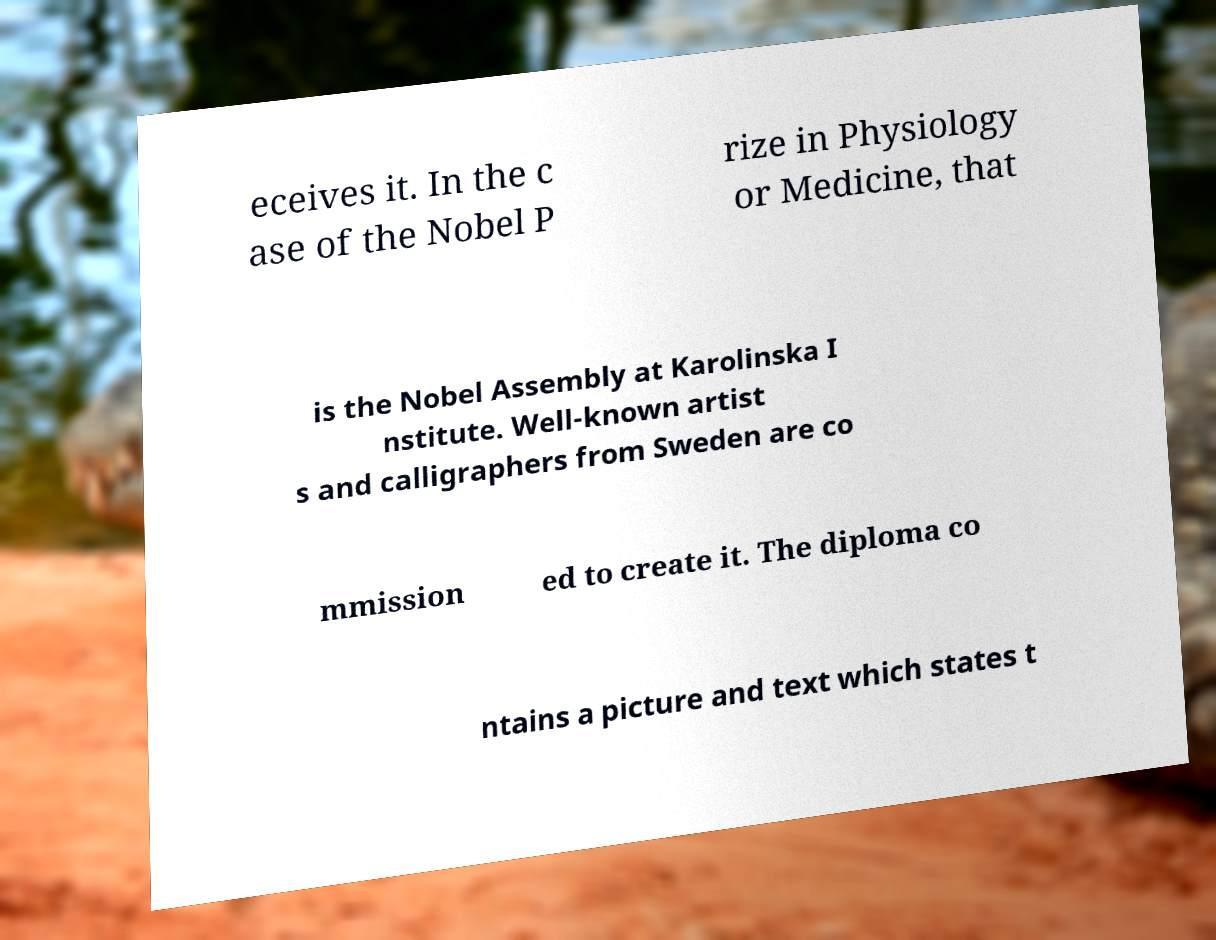Please read and relay the text visible in this image. What does it say? eceives it. In the c ase of the Nobel P rize in Physiology or Medicine, that is the Nobel Assembly at Karolinska I nstitute. Well-known artist s and calligraphers from Sweden are co mmission ed to create it. The diploma co ntains a picture and text which states t 